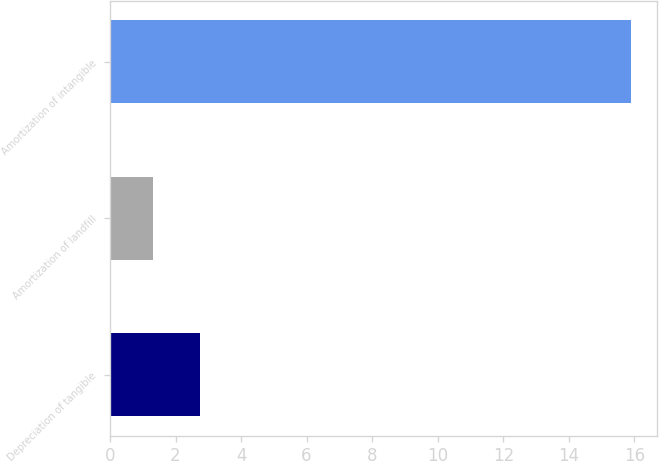Convert chart to OTSL. <chart><loc_0><loc_0><loc_500><loc_500><bar_chart><fcel>Depreciation of tangible<fcel>Amortization of landfill<fcel>Amortization of intangible<nl><fcel>2.76<fcel>1.3<fcel>15.9<nl></chart> 